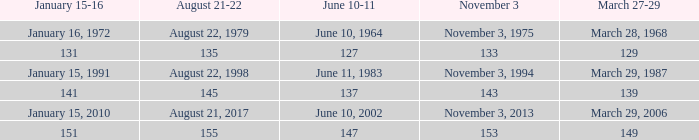 november 3 where march 27-29 is 149? 153.0. 